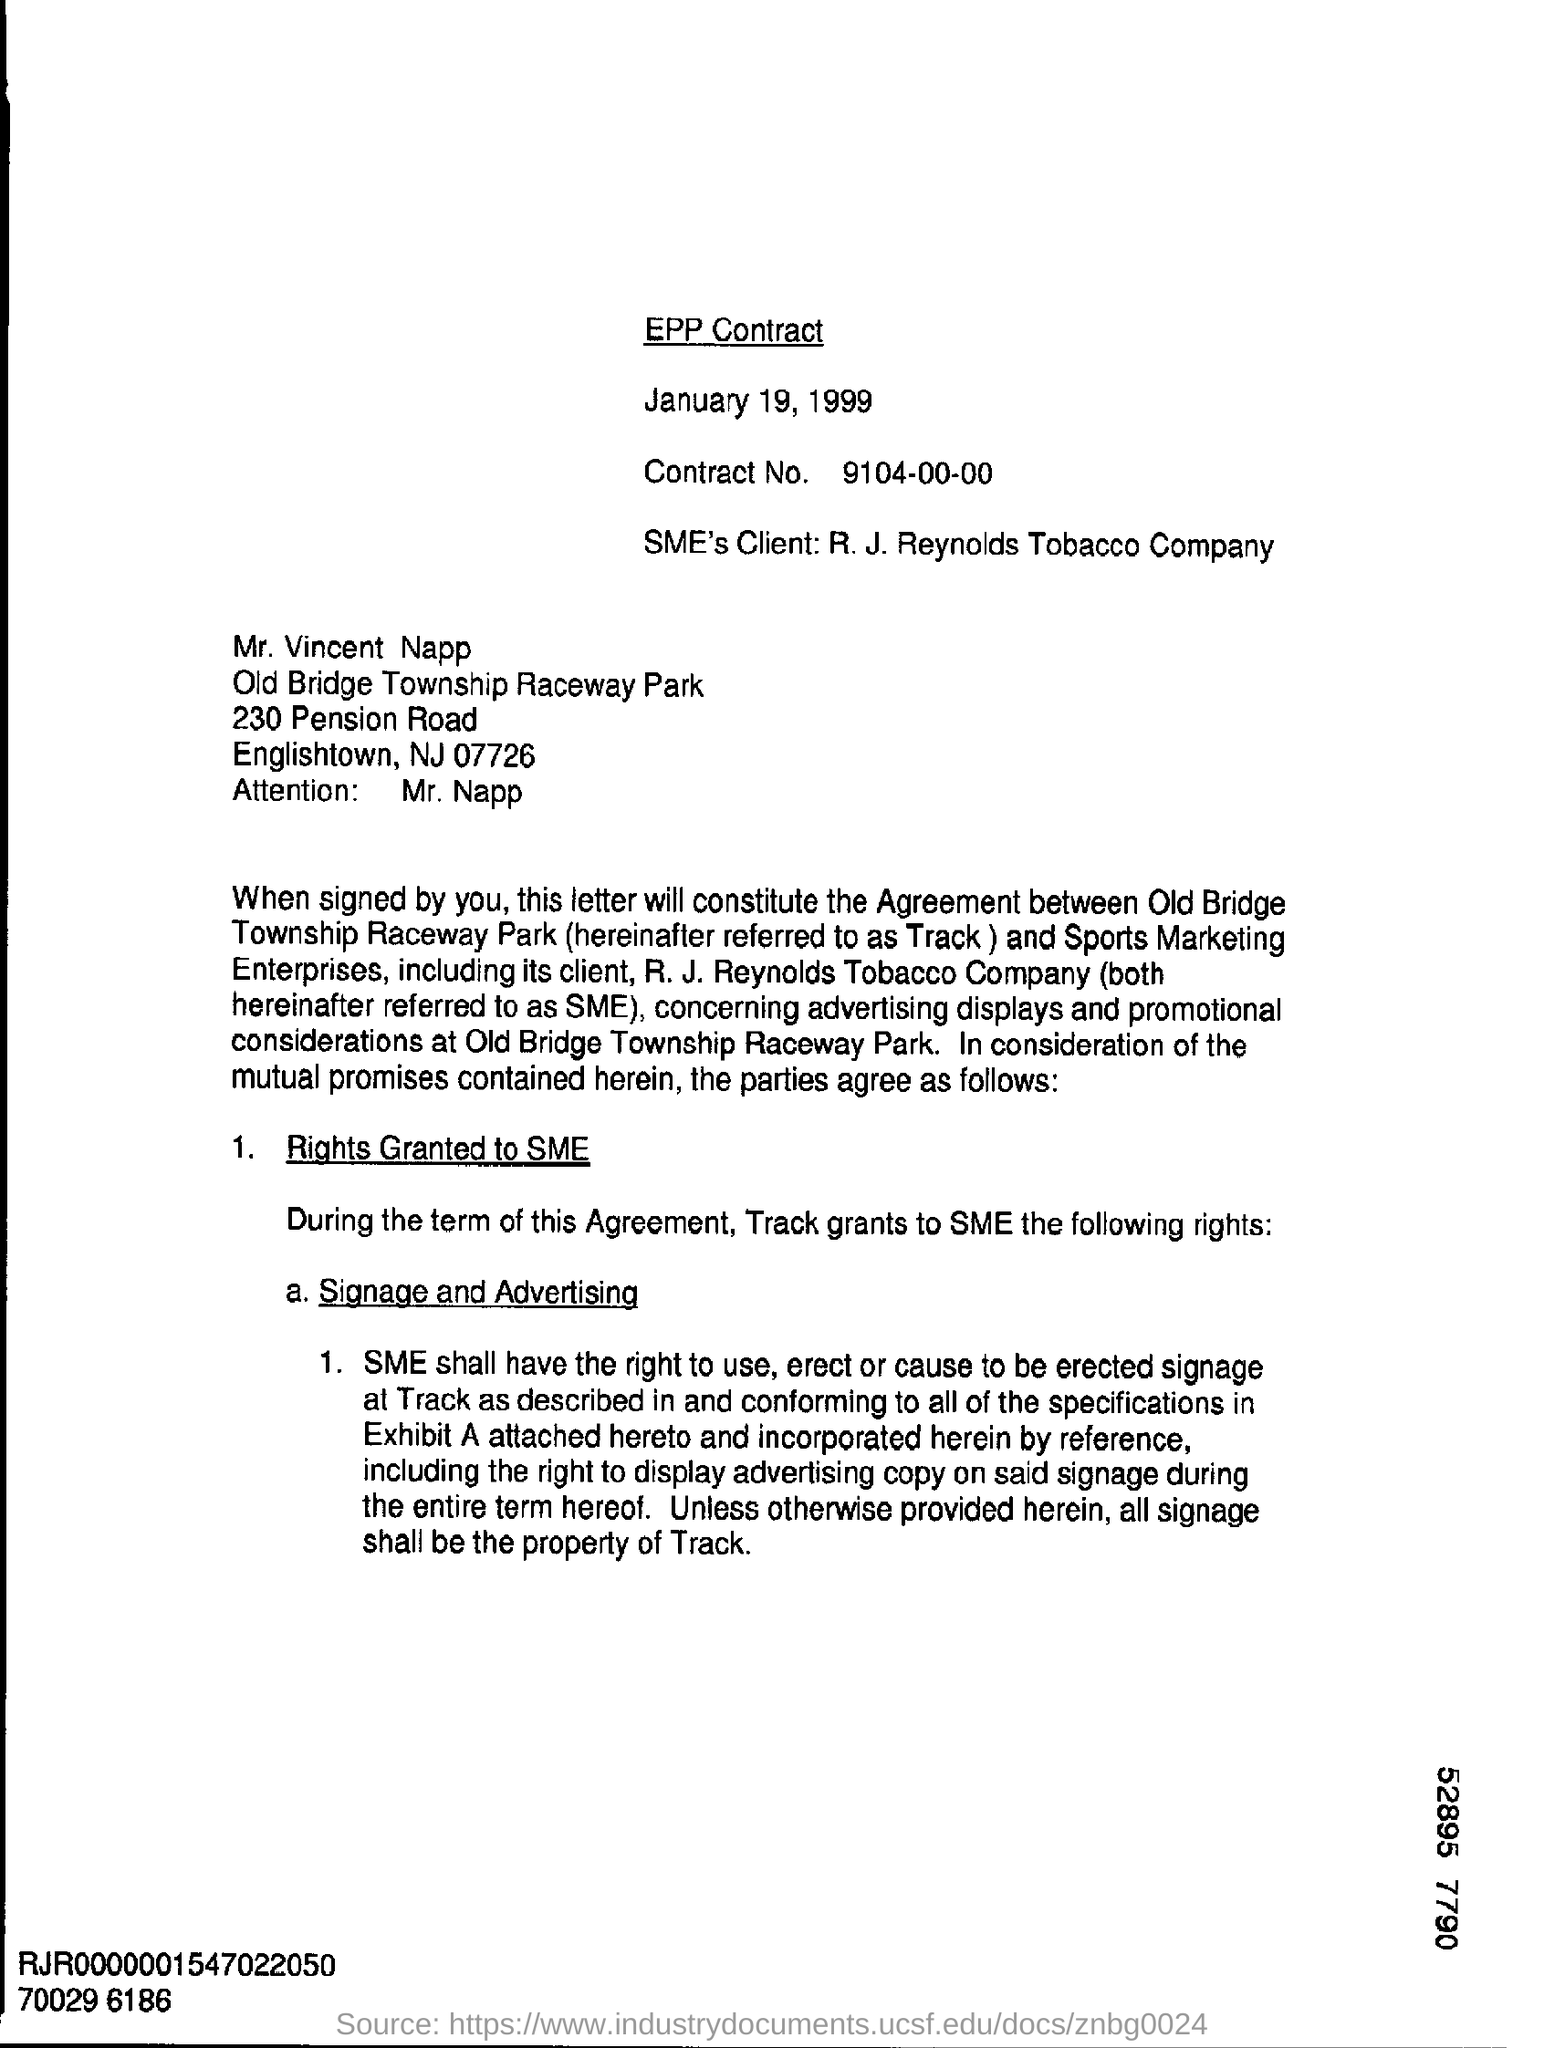What rights are being granted to SME in this agreement? According to the document, SME (Sports Marketing Enterprises) is granted the rights to use, erect, or cause to be erected signage at the Track as described in the agreement and its Exhibit A. This includes the right to display advertising copy on said signage throughout the term of the agreement. All signage shall be the property of the Track. 